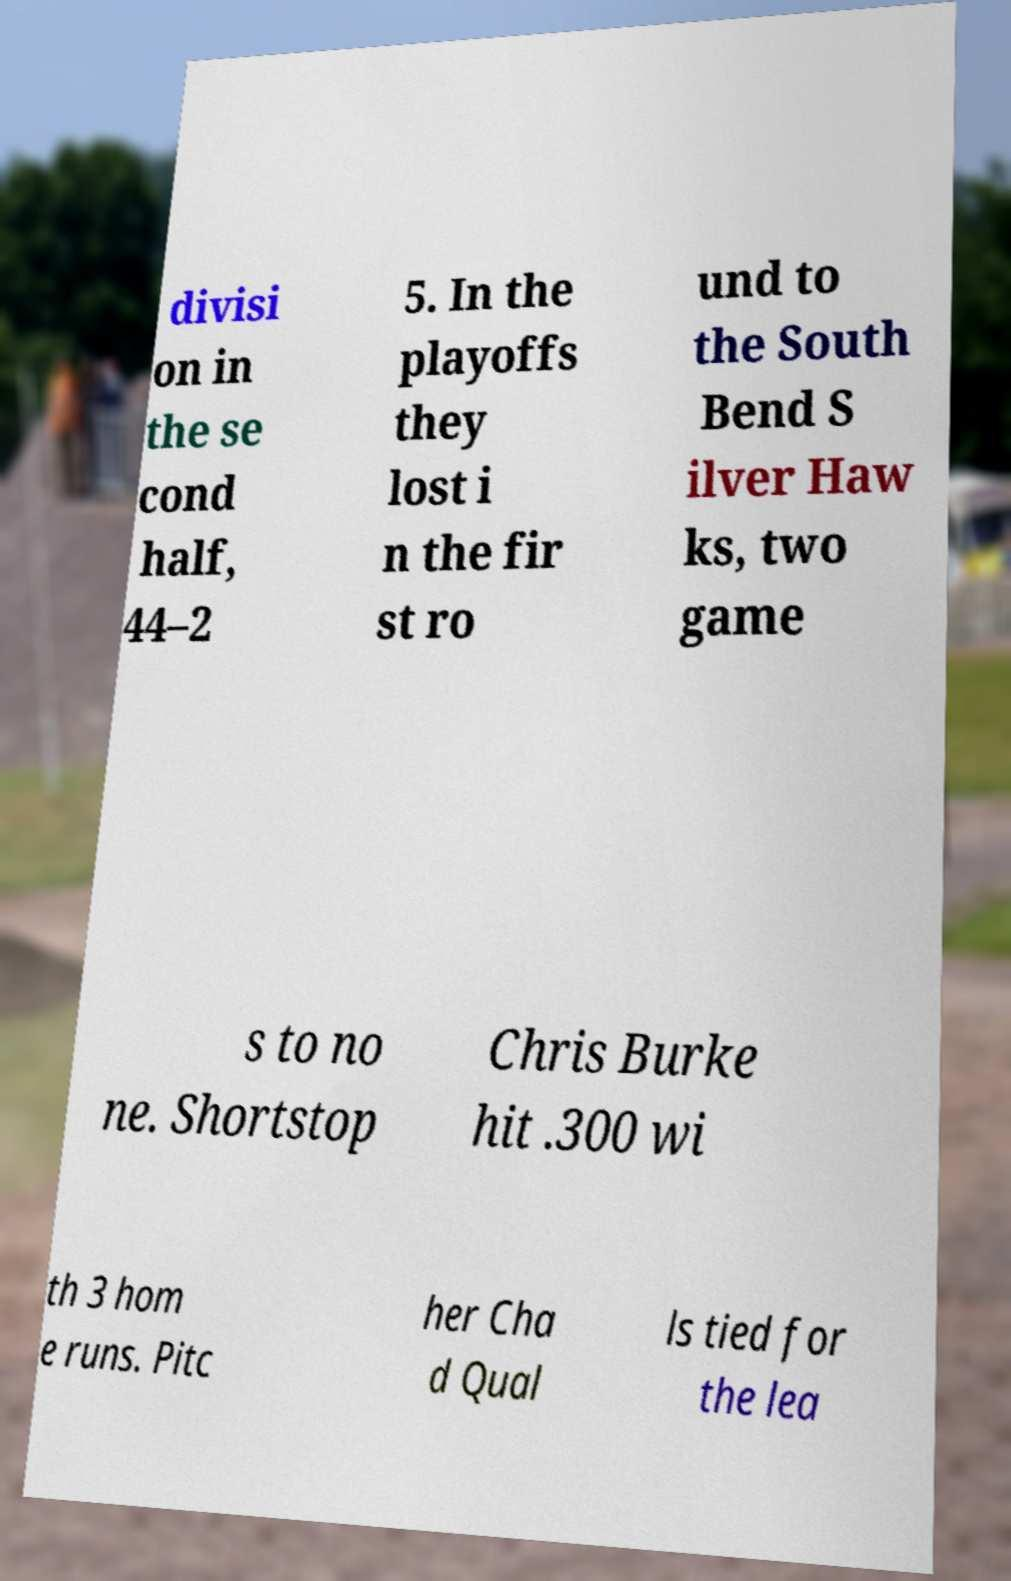What messages or text are displayed in this image? I need them in a readable, typed format. divisi on in the se cond half, 44–2 5. In the playoffs they lost i n the fir st ro und to the South Bend S ilver Haw ks, two game s to no ne. Shortstop Chris Burke hit .300 wi th 3 hom e runs. Pitc her Cha d Qual ls tied for the lea 